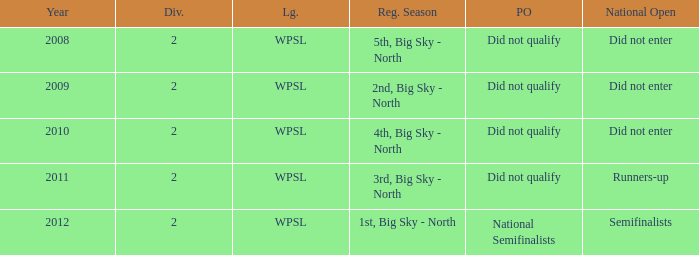What was the regular season name where they did not qualify for the playoffs in 2009? 2nd, Big Sky - North. 